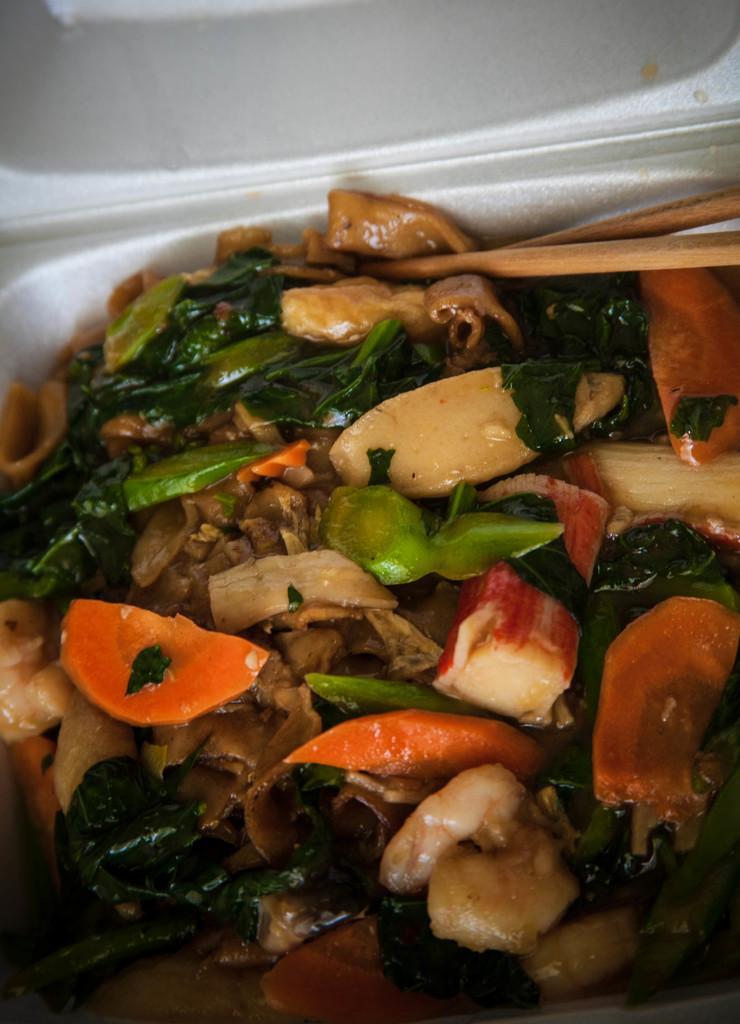Please provide a concise description of this image. In this image, we can see eatable things, some items, chopsticks are placed on the white bowl. Here we can see a white color cap. 